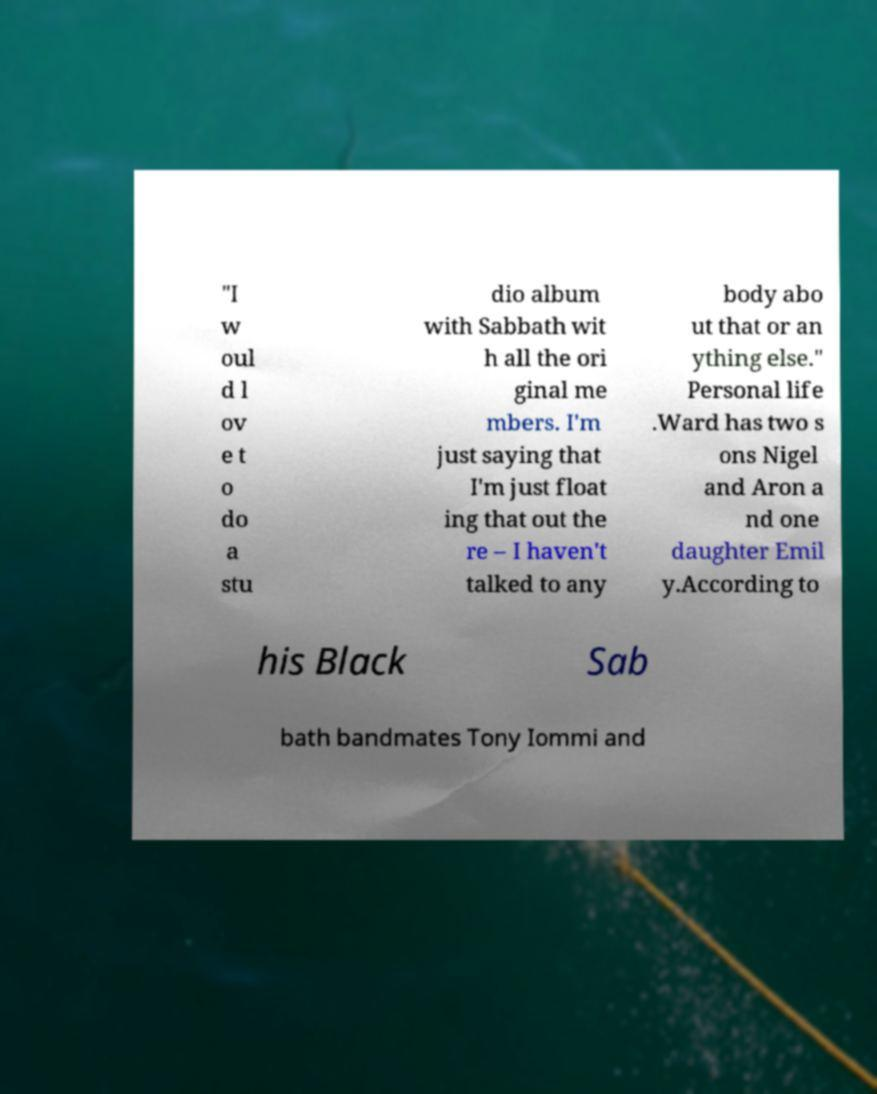Could you assist in decoding the text presented in this image and type it out clearly? "I w oul d l ov e t o do a stu dio album with Sabbath wit h all the ori ginal me mbers. I'm just saying that I'm just float ing that out the re – I haven't talked to any body abo ut that or an ything else." Personal life .Ward has two s ons Nigel and Aron a nd one daughter Emil y.According to his Black Sab bath bandmates Tony Iommi and 